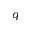Convert formula to latex. <formula><loc_0><loc_0><loc_500><loc_500>q</formula> 